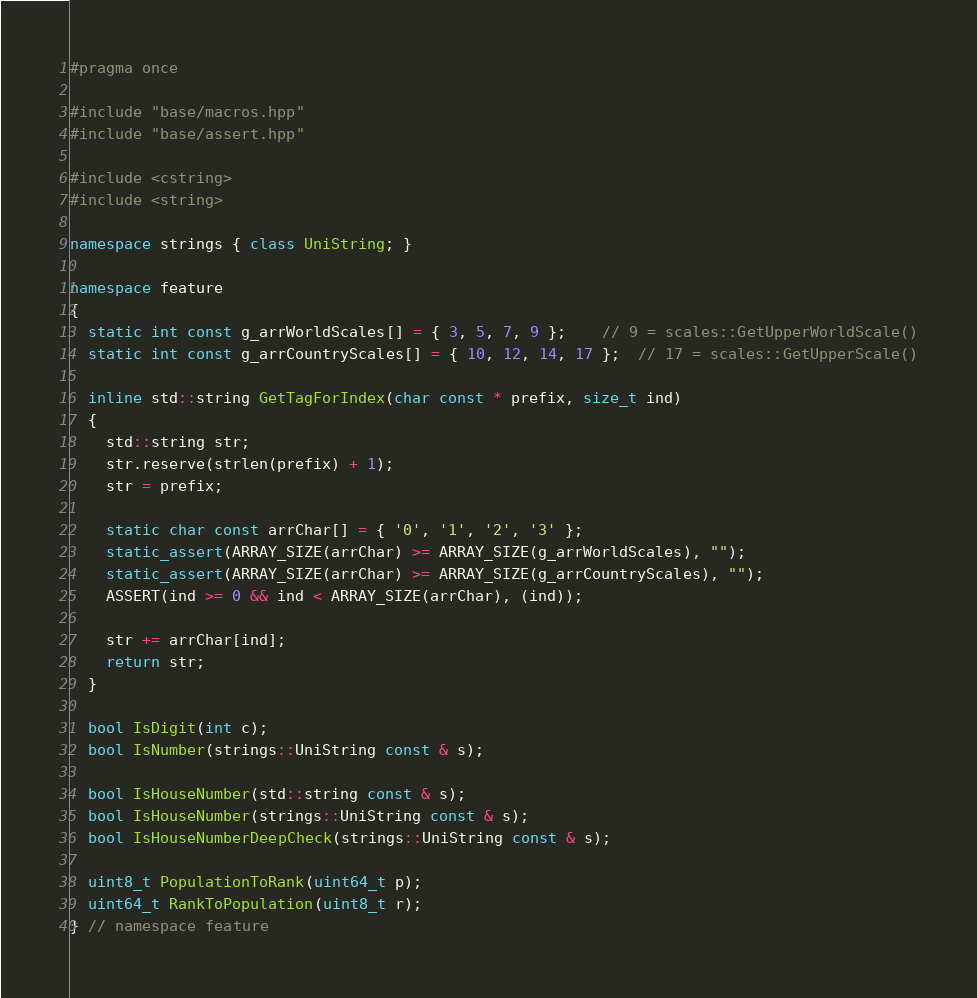Convert code to text. <code><loc_0><loc_0><loc_500><loc_500><_C++_>#pragma once

#include "base/macros.hpp"
#include "base/assert.hpp"

#include <cstring>
#include <string>

namespace strings { class UniString; }

namespace feature
{
  static int const g_arrWorldScales[] = { 3, 5, 7, 9 };    // 9 = scales::GetUpperWorldScale()
  static int const g_arrCountryScales[] = { 10, 12, 14, 17 };  // 17 = scales::GetUpperScale()

  inline std::string GetTagForIndex(char const * prefix, size_t ind)
  {
    std::string str;
    str.reserve(strlen(prefix) + 1);
    str = prefix;

    static char const arrChar[] = { '0', '1', '2', '3' };
    static_assert(ARRAY_SIZE(arrChar) >= ARRAY_SIZE(g_arrWorldScales), "");
    static_assert(ARRAY_SIZE(arrChar) >= ARRAY_SIZE(g_arrCountryScales), "");
    ASSERT(ind >= 0 && ind < ARRAY_SIZE(arrChar), (ind));

    str += arrChar[ind];
    return str;
  }

  bool IsDigit(int c);
  bool IsNumber(strings::UniString const & s);

  bool IsHouseNumber(std::string const & s);
  bool IsHouseNumber(strings::UniString const & s);
  bool IsHouseNumberDeepCheck(strings::UniString const & s);

  uint8_t PopulationToRank(uint64_t p);
  uint64_t RankToPopulation(uint8_t r);
} // namespace feature
</code> 